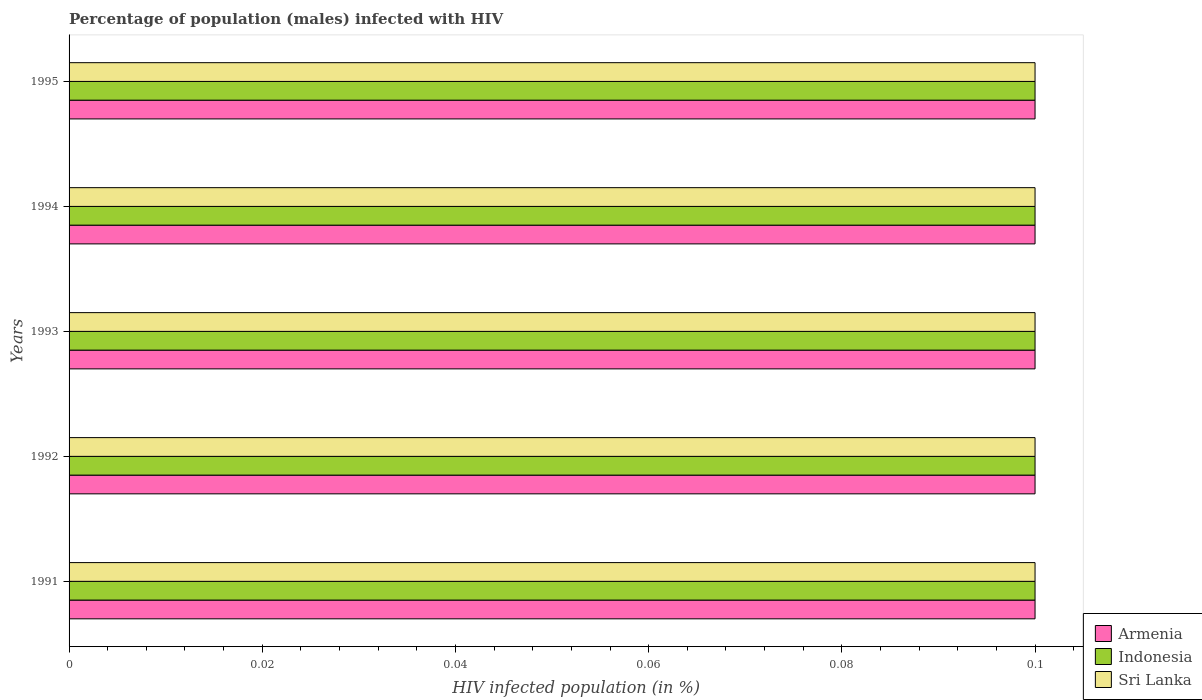How many different coloured bars are there?
Your answer should be compact. 3. How many groups of bars are there?
Give a very brief answer. 5. How many bars are there on the 3rd tick from the top?
Ensure brevity in your answer.  3. Across all years, what is the maximum percentage of HIV infected male population in Armenia?
Your answer should be very brief. 0.1. Across all years, what is the minimum percentage of HIV infected male population in Indonesia?
Offer a very short reply. 0.1. In which year was the percentage of HIV infected male population in Sri Lanka maximum?
Your answer should be very brief. 1991. What is the difference between the percentage of HIV infected male population in Sri Lanka in 1991 and that in 1995?
Ensure brevity in your answer.  0. What is the difference between the percentage of HIV infected male population in Indonesia in 1993 and the percentage of HIV infected male population in Armenia in 1995?
Give a very brief answer. 0. What is the average percentage of HIV infected male population in Armenia per year?
Your answer should be very brief. 0.1. What is the ratio of the percentage of HIV infected male population in Sri Lanka in 1991 to that in 1995?
Your answer should be very brief. 1. Is the percentage of HIV infected male population in Indonesia in 1991 less than that in 1993?
Your answer should be very brief. No. Is the difference between the percentage of HIV infected male population in Sri Lanka in 1993 and 1994 greater than the difference between the percentage of HIV infected male population in Indonesia in 1993 and 1994?
Provide a succinct answer. No. Is the sum of the percentage of HIV infected male population in Armenia in 1992 and 1994 greater than the maximum percentage of HIV infected male population in Sri Lanka across all years?
Provide a succinct answer. Yes. What does the 1st bar from the bottom in 1995 represents?
Make the answer very short. Armenia. How many bars are there?
Your response must be concise. 15. How many years are there in the graph?
Your answer should be compact. 5. Are the values on the major ticks of X-axis written in scientific E-notation?
Your answer should be very brief. No. Where does the legend appear in the graph?
Your answer should be compact. Bottom right. How are the legend labels stacked?
Keep it short and to the point. Vertical. What is the title of the graph?
Provide a short and direct response. Percentage of population (males) infected with HIV. Does "Sub-Saharan Africa (developing only)" appear as one of the legend labels in the graph?
Give a very brief answer. No. What is the label or title of the X-axis?
Offer a very short reply. HIV infected population (in %). What is the label or title of the Y-axis?
Provide a short and direct response. Years. What is the HIV infected population (in %) in Indonesia in 1991?
Your answer should be compact. 0.1. What is the HIV infected population (in %) of Indonesia in 1993?
Offer a very short reply. 0.1. What is the HIV infected population (in %) of Armenia in 1994?
Ensure brevity in your answer.  0.1. What is the HIV infected population (in %) in Indonesia in 1994?
Provide a short and direct response. 0.1. What is the HIV infected population (in %) of Armenia in 1995?
Offer a terse response. 0.1. Across all years, what is the maximum HIV infected population (in %) of Indonesia?
Offer a terse response. 0.1. Across all years, what is the maximum HIV infected population (in %) in Sri Lanka?
Ensure brevity in your answer.  0.1. Across all years, what is the minimum HIV infected population (in %) in Sri Lanka?
Your response must be concise. 0.1. What is the total HIV infected population (in %) in Indonesia in the graph?
Keep it short and to the point. 0.5. What is the total HIV infected population (in %) of Sri Lanka in the graph?
Provide a succinct answer. 0.5. What is the difference between the HIV infected population (in %) of Sri Lanka in 1991 and that in 1992?
Provide a succinct answer. 0. What is the difference between the HIV infected population (in %) in Armenia in 1991 and that in 1993?
Your answer should be compact. 0. What is the difference between the HIV infected population (in %) in Sri Lanka in 1991 and that in 1994?
Provide a short and direct response. 0. What is the difference between the HIV infected population (in %) of Armenia in 1991 and that in 1995?
Give a very brief answer. 0. What is the difference between the HIV infected population (in %) in Indonesia in 1992 and that in 1993?
Provide a short and direct response. 0. What is the difference between the HIV infected population (in %) in Sri Lanka in 1992 and that in 1993?
Offer a very short reply. 0. What is the difference between the HIV infected population (in %) in Indonesia in 1992 and that in 1994?
Keep it short and to the point. 0. What is the difference between the HIV infected population (in %) in Armenia in 1992 and that in 1995?
Give a very brief answer. 0. What is the difference between the HIV infected population (in %) of Indonesia in 1992 and that in 1995?
Your response must be concise. 0. What is the difference between the HIV infected population (in %) in Sri Lanka in 1992 and that in 1995?
Give a very brief answer. 0. What is the difference between the HIV infected population (in %) in Armenia in 1993 and that in 1994?
Your answer should be very brief. 0. What is the difference between the HIV infected population (in %) in Sri Lanka in 1993 and that in 1995?
Keep it short and to the point. 0. What is the difference between the HIV infected population (in %) in Armenia in 1991 and the HIV infected population (in %) in Sri Lanka in 1992?
Provide a short and direct response. 0. What is the difference between the HIV infected population (in %) in Armenia in 1991 and the HIV infected population (in %) in Indonesia in 1993?
Keep it short and to the point. 0. What is the difference between the HIV infected population (in %) of Armenia in 1991 and the HIV infected population (in %) of Sri Lanka in 1993?
Give a very brief answer. 0. What is the difference between the HIV infected population (in %) in Armenia in 1991 and the HIV infected population (in %) in Indonesia in 1994?
Provide a succinct answer. 0. What is the difference between the HIV infected population (in %) in Indonesia in 1991 and the HIV infected population (in %) in Sri Lanka in 1994?
Ensure brevity in your answer.  0. What is the difference between the HIV infected population (in %) of Armenia in 1991 and the HIV infected population (in %) of Sri Lanka in 1995?
Offer a very short reply. 0. What is the difference between the HIV infected population (in %) of Armenia in 1992 and the HIV infected population (in %) of Indonesia in 1993?
Keep it short and to the point. 0. What is the difference between the HIV infected population (in %) of Armenia in 1992 and the HIV infected population (in %) of Sri Lanka in 1993?
Make the answer very short. 0. What is the difference between the HIV infected population (in %) in Armenia in 1992 and the HIV infected population (in %) in Indonesia in 1994?
Your answer should be very brief. 0. What is the difference between the HIV infected population (in %) of Armenia in 1992 and the HIV infected population (in %) of Sri Lanka in 1994?
Keep it short and to the point. 0. What is the difference between the HIV infected population (in %) in Armenia in 1992 and the HIV infected population (in %) in Indonesia in 1995?
Offer a very short reply. 0. What is the difference between the HIV infected population (in %) of Indonesia in 1992 and the HIV infected population (in %) of Sri Lanka in 1995?
Offer a very short reply. 0. What is the difference between the HIV infected population (in %) of Armenia in 1993 and the HIV infected population (in %) of Sri Lanka in 1994?
Ensure brevity in your answer.  0. What is the difference between the HIV infected population (in %) in Indonesia in 1993 and the HIV infected population (in %) in Sri Lanka in 1994?
Offer a very short reply. 0. What is the difference between the HIV infected population (in %) of Armenia in 1993 and the HIV infected population (in %) of Sri Lanka in 1995?
Offer a terse response. 0. What is the difference between the HIV infected population (in %) of Indonesia in 1993 and the HIV infected population (in %) of Sri Lanka in 1995?
Provide a short and direct response. 0. What is the difference between the HIV infected population (in %) of Armenia in 1994 and the HIV infected population (in %) of Sri Lanka in 1995?
Make the answer very short. 0. What is the average HIV infected population (in %) in Indonesia per year?
Make the answer very short. 0.1. In the year 1991, what is the difference between the HIV infected population (in %) in Armenia and HIV infected population (in %) in Indonesia?
Offer a very short reply. 0. In the year 1992, what is the difference between the HIV infected population (in %) in Indonesia and HIV infected population (in %) in Sri Lanka?
Make the answer very short. 0. In the year 1993, what is the difference between the HIV infected population (in %) of Armenia and HIV infected population (in %) of Indonesia?
Your answer should be compact. 0. In the year 1993, what is the difference between the HIV infected population (in %) in Indonesia and HIV infected population (in %) in Sri Lanka?
Make the answer very short. 0. In the year 1994, what is the difference between the HIV infected population (in %) in Armenia and HIV infected population (in %) in Indonesia?
Offer a terse response. 0. In the year 1994, what is the difference between the HIV infected population (in %) in Armenia and HIV infected population (in %) in Sri Lanka?
Ensure brevity in your answer.  0. What is the ratio of the HIV infected population (in %) in Sri Lanka in 1991 to that in 1992?
Keep it short and to the point. 1. What is the ratio of the HIV infected population (in %) in Armenia in 1991 to that in 1993?
Ensure brevity in your answer.  1. What is the ratio of the HIV infected population (in %) in Armenia in 1991 to that in 1994?
Your response must be concise. 1. What is the ratio of the HIV infected population (in %) of Indonesia in 1991 to that in 1994?
Your answer should be very brief. 1. What is the ratio of the HIV infected population (in %) of Sri Lanka in 1991 to that in 1994?
Give a very brief answer. 1. What is the ratio of the HIV infected population (in %) of Armenia in 1992 to that in 1993?
Your answer should be very brief. 1. What is the ratio of the HIV infected population (in %) of Indonesia in 1992 to that in 1994?
Offer a very short reply. 1. What is the ratio of the HIV infected population (in %) in Sri Lanka in 1992 to that in 1994?
Your answer should be very brief. 1. What is the ratio of the HIV infected population (in %) of Armenia in 1992 to that in 1995?
Make the answer very short. 1. What is the ratio of the HIV infected population (in %) of Sri Lanka in 1992 to that in 1995?
Give a very brief answer. 1. What is the ratio of the HIV infected population (in %) of Armenia in 1993 to that in 1994?
Your answer should be compact. 1. What is the ratio of the HIV infected population (in %) of Indonesia in 1993 to that in 1994?
Ensure brevity in your answer.  1. What is the ratio of the HIV infected population (in %) in Sri Lanka in 1993 to that in 1994?
Your response must be concise. 1. What is the ratio of the HIV infected population (in %) of Sri Lanka in 1993 to that in 1995?
Offer a very short reply. 1. What is the ratio of the HIV infected population (in %) in Armenia in 1994 to that in 1995?
Give a very brief answer. 1. What is the ratio of the HIV infected population (in %) in Indonesia in 1994 to that in 1995?
Ensure brevity in your answer.  1. What is the ratio of the HIV infected population (in %) of Sri Lanka in 1994 to that in 1995?
Ensure brevity in your answer.  1. What is the difference between the highest and the second highest HIV infected population (in %) of Sri Lanka?
Offer a terse response. 0. 